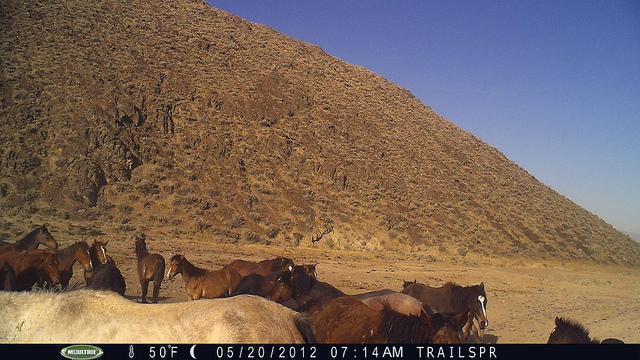What is the term used to call this group of horses?
Indicate the correct response by choosing from the four available options to answer the question.
Options: Stampede, herd, wave, slide. Herd. 